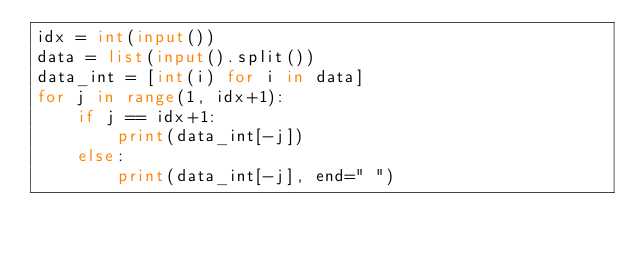<code> <loc_0><loc_0><loc_500><loc_500><_Python_>idx = int(input())
data = list(input().split())
data_int = [int(i) for i in data]
for j in range(1, idx+1):
    if j == idx+1:
        print(data_int[-j])
    else:
        print(data_int[-j], end=" ")</code> 